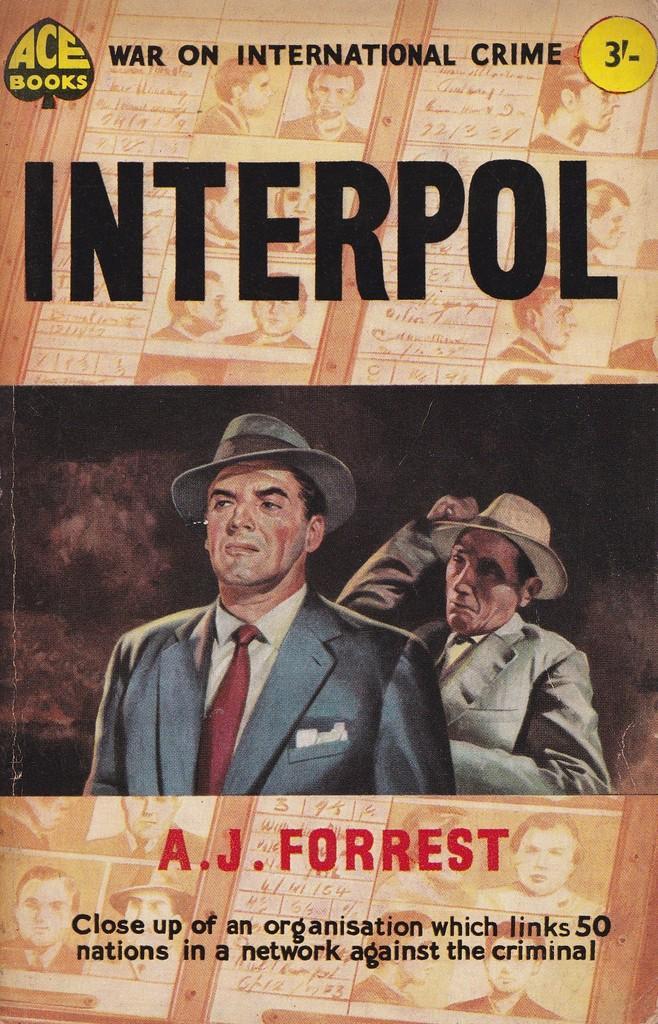Could you give a brief overview of what you see in this image? This is a poster with something written on that. Also there are two persons wearing hats. 